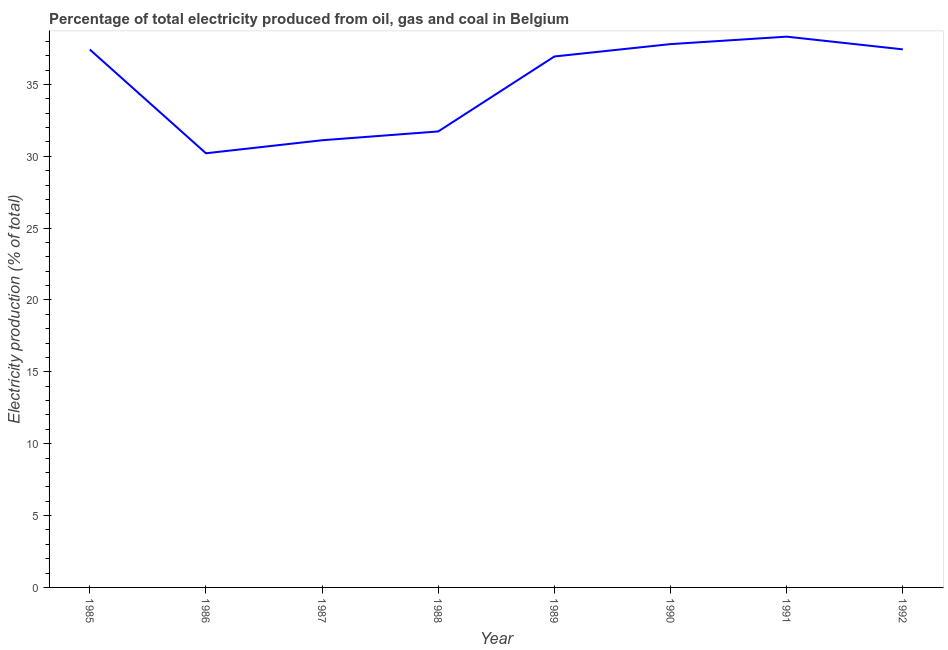What is the electricity production in 1991?
Provide a succinct answer. 38.32. Across all years, what is the maximum electricity production?
Give a very brief answer. 38.32. Across all years, what is the minimum electricity production?
Offer a very short reply. 30.21. In which year was the electricity production maximum?
Your answer should be very brief. 1991. What is the sum of the electricity production?
Offer a very short reply. 280.99. What is the difference between the electricity production in 1989 and 1991?
Keep it short and to the point. -1.38. What is the average electricity production per year?
Keep it short and to the point. 35.12. What is the median electricity production?
Offer a terse response. 37.19. In how many years, is the electricity production greater than 10 %?
Your answer should be compact. 8. What is the ratio of the electricity production in 1987 to that in 1988?
Provide a short and direct response. 0.98. What is the difference between the highest and the second highest electricity production?
Offer a very short reply. 0.52. What is the difference between the highest and the lowest electricity production?
Your answer should be very brief. 8.11. In how many years, is the electricity production greater than the average electricity production taken over all years?
Keep it short and to the point. 5. Does the electricity production monotonically increase over the years?
Your answer should be compact. No. How many years are there in the graph?
Offer a terse response. 8. What is the difference between two consecutive major ticks on the Y-axis?
Make the answer very short. 5. What is the title of the graph?
Ensure brevity in your answer.  Percentage of total electricity produced from oil, gas and coal in Belgium. What is the label or title of the Y-axis?
Provide a short and direct response. Electricity production (% of total). What is the Electricity production (% of total) in 1985?
Provide a succinct answer. 37.43. What is the Electricity production (% of total) of 1986?
Your response must be concise. 30.21. What is the Electricity production (% of total) of 1987?
Your answer should be very brief. 31.11. What is the Electricity production (% of total) of 1988?
Keep it short and to the point. 31.73. What is the Electricity production (% of total) of 1989?
Provide a short and direct response. 36.94. What is the Electricity production (% of total) of 1990?
Provide a short and direct response. 37.81. What is the Electricity production (% of total) of 1991?
Your response must be concise. 38.32. What is the Electricity production (% of total) of 1992?
Ensure brevity in your answer.  37.44. What is the difference between the Electricity production (% of total) in 1985 and 1986?
Ensure brevity in your answer.  7.22. What is the difference between the Electricity production (% of total) in 1985 and 1987?
Provide a succinct answer. 6.31. What is the difference between the Electricity production (% of total) in 1985 and 1988?
Your answer should be very brief. 5.7. What is the difference between the Electricity production (% of total) in 1985 and 1989?
Your answer should be very brief. 0.48. What is the difference between the Electricity production (% of total) in 1985 and 1990?
Keep it short and to the point. -0.38. What is the difference between the Electricity production (% of total) in 1985 and 1991?
Keep it short and to the point. -0.89. What is the difference between the Electricity production (% of total) in 1985 and 1992?
Provide a succinct answer. -0.01. What is the difference between the Electricity production (% of total) in 1986 and 1987?
Provide a short and direct response. -0.91. What is the difference between the Electricity production (% of total) in 1986 and 1988?
Offer a very short reply. -1.52. What is the difference between the Electricity production (% of total) in 1986 and 1989?
Your answer should be very brief. -6.73. What is the difference between the Electricity production (% of total) in 1986 and 1990?
Make the answer very short. -7.6. What is the difference between the Electricity production (% of total) in 1986 and 1991?
Provide a short and direct response. -8.11. What is the difference between the Electricity production (% of total) in 1986 and 1992?
Offer a very short reply. -7.23. What is the difference between the Electricity production (% of total) in 1987 and 1988?
Give a very brief answer. -0.61. What is the difference between the Electricity production (% of total) in 1987 and 1989?
Ensure brevity in your answer.  -5.83. What is the difference between the Electricity production (% of total) in 1987 and 1990?
Your answer should be very brief. -6.69. What is the difference between the Electricity production (% of total) in 1987 and 1991?
Your response must be concise. -7.21. What is the difference between the Electricity production (% of total) in 1987 and 1992?
Ensure brevity in your answer.  -6.32. What is the difference between the Electricity production (% of total) in 1988 and 1989?
Your answer should be very brief. -5.22. What is the difference between the Electricity production (% of total) in 1988 and 1990?
Your answer should be compact. -6.08. What is the difference between the Electricity production (% of total) in 1988 and 1991?
Offer a terse response. -6.59. What is the difference between the Electricity production (% of total) in 1988 and 1992?
Make the answer very short. -5.71. What is the difference between the Electricity production (% of total) in 1989 and 1990?
Provide a succinct answer. -0.86. What is the difference between the Electricity production (% of total) in 1989 and 1991?
Keep it short and to the point. -1.38. What is the difference between the Electricity production (% of total) in 1989 and 1992?
Provide a short and direct response. -0.49. What is the difference between the Electricity production (% of total) in 1990 and 1991?
Provide a succinct answer. -0.52. What is the difference between the Electricity production (% of total) in 1990 and 1992?
Your answer should be compact. 0.37. What is the difference between the Electricity production (% of total) in 1991 and 1992?
Ensure brevity in your answer.  0.88. What is the ratio of the Electricity production (% of total) in 1985 to that in 1986?
Your response must be concise. 1.24. What is the ratio of the Electricity production (% of total) in 1985 to that in 1987?
Offer a very short reply. 1.2. What is the ratio of the Electricity production (% of total) in 1985 to that in 1988?
Provide a short and direct response. 1.18. What is the ratio of the Electricity production (% of total) in 1985 to that in 1989?
Keep it short and to the point. 1.01. What is the ratio of the Electricity production (% of total) in 1985 to that in 1992?
Provide a short and direct response. 1. What is the ratio of the Electricity production (% of total) in 1986 to that in 1987?
Offer a terse response. 0.97. What is the ratio of the Electricity production (% of total) in 1986 to that in 1989?
Offer a terse response. 0.82. What is the ratio of the Electricity production (% of total) in 1986 to that in 1990?
Give a very brief answer. 0.8. What is the ratio of the Electricity production (% of total) in 1986 to that in 1991?
Give a very brief answer. 0.79. What is the ratio of the Electricity production (% of total) in 1986 to that in 1992?
Ensure brevity in your answer.  0.81. What is the ratio of the Electricity production (% of total) in 1987 to that in 1988?
Your answer should be very brief. 0.98. What is the ratio of the Electricity production (% of total) in 1987 to that in 1989?
Provide a short and direct response. 0.84. What is the ratio of the Electricity production (% of total) in 1987 to that in 1990?
Ensure brevity in your answer.  0.82. What is the ratio of the Electricity production (% of total) in 1987 to that in 1991?
Make the answer very short. 0.81. What is the ratio of the Electricity production (% of total) in 1987 to that in 1992?
Keep it short and to the point. 0.83. What is the ratio of the Electricity production (% of total) in 1988 to that in 1989?
Your response must be concise. 0.86. What is the ratio of the Electricity production (% of total) in 1988 to that in 1990?
Ensure brevity in your answer.  0.84. What is the ratio of the Electricity production (% of total) in 1988 to that in 1991?
Your answer should be very brief. 0.83. What is the ratio of the Electricity production (% of total) in 1988 to that in 1992?
Give a very brief answer. 0.85. What is the ratio of the Electricity production (% of total) in 1989 to that in 1991?
Give a very brief answer. 0.96. What is the ratio of the Electricity production (% of total) in 1990 to that in 1992?
Offer a very short reply. 1.01. What is the ratio of the Electricity production (% of total) in 1991 to that in 1992?
Provide a short and direct response. 1.02. 